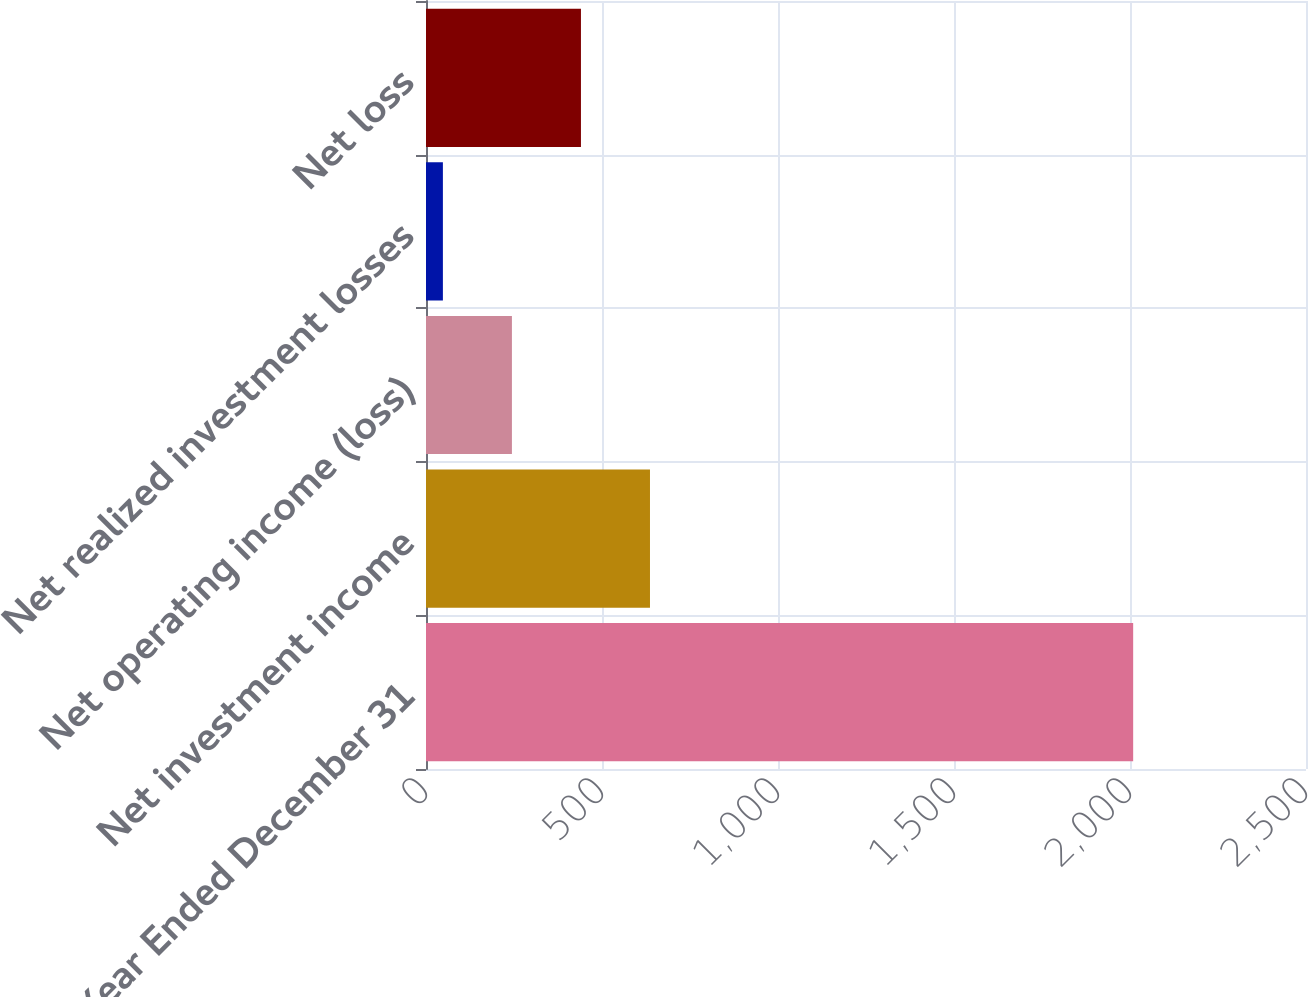<chart> <loc_0><loc_0><loc_500><loc_500><bar_chart><fcel>Year Ended December 31<fcel>Net investment income<fcel>Net operating income (loss)<fcel>Net realized investment losses<fcel>Net loss<nl><fcel>2009<fcel>636.3<fcel>244.1<fcel>48<fcel>440.2<nl></chart> 